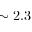<formula> <loc_0><loc_0><loc_500><loc_500>\sim 2 . 3</formula> 